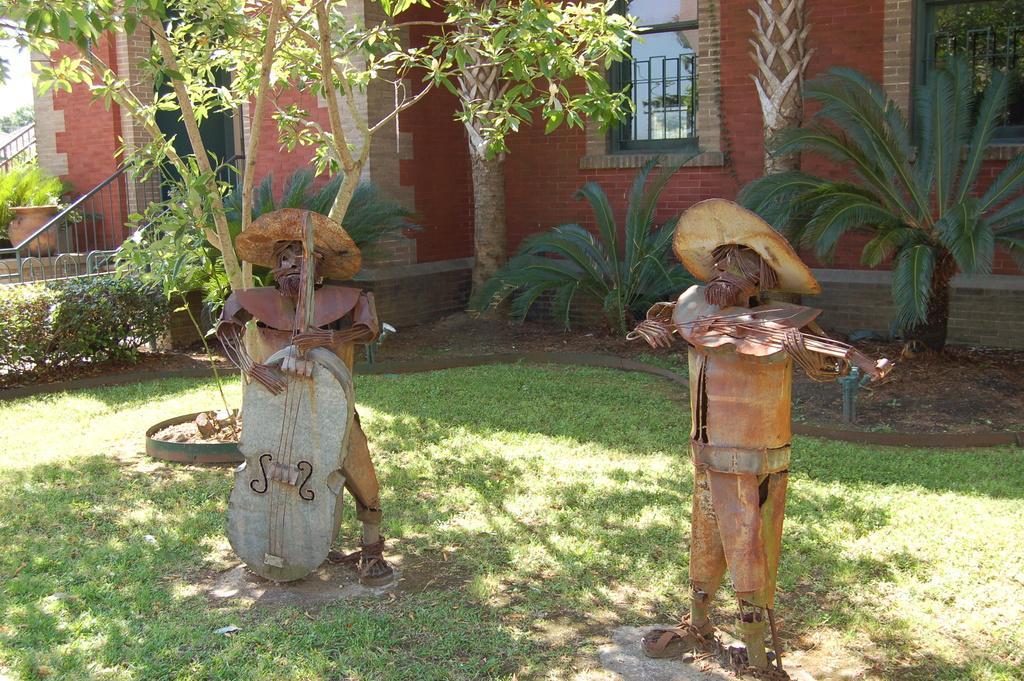Please provide a concise description of this image. In this image I can see grass ground and on it I can see two sculptures. In the background I can see number of plants, few trees, railings and a red colour building. I can also see two windows on the top right side of this image. 